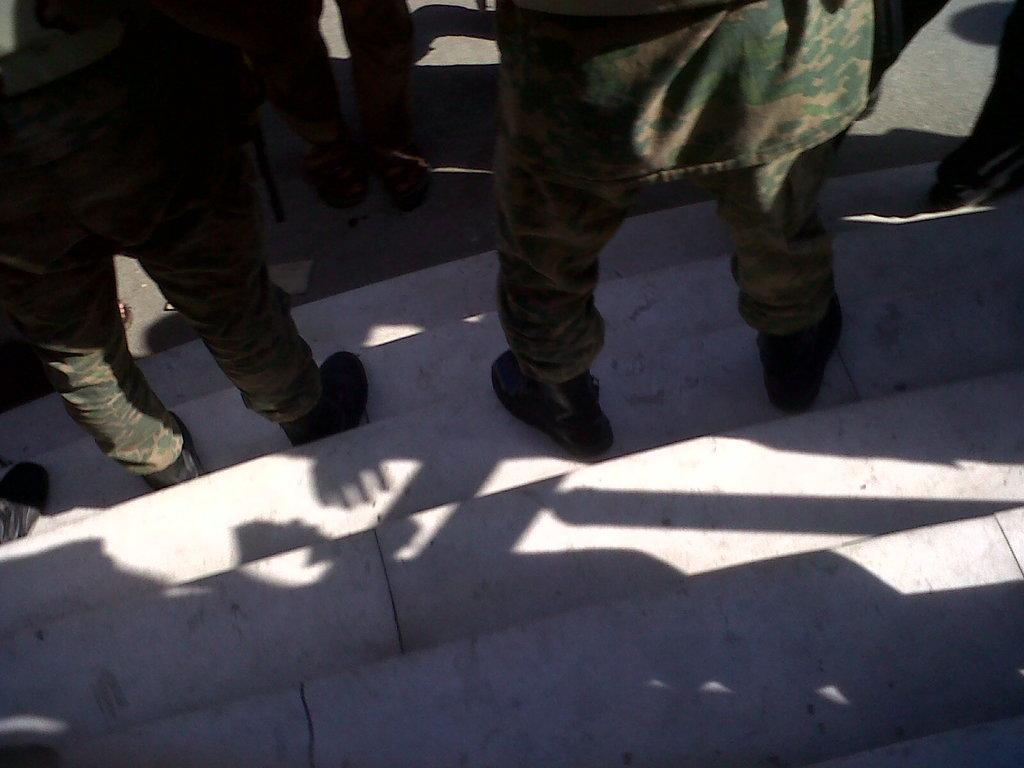What type of people are in the image? There are men in the image. What are the men wearing? The men are wearing uniforms and shoes. Where are the men located in the image? The men are standing on a staircase. What can be seen beside the staircase in the image? There is a road visible beside the staircase. What type of memory is stored in the staircase in the image? There is no memory storage device present in the image; it features men standing on a staircase. How does the rail affect the movement of the men in the image? There is no rail mentioned in the image; the men are standing on a staircase without any visible railing. 